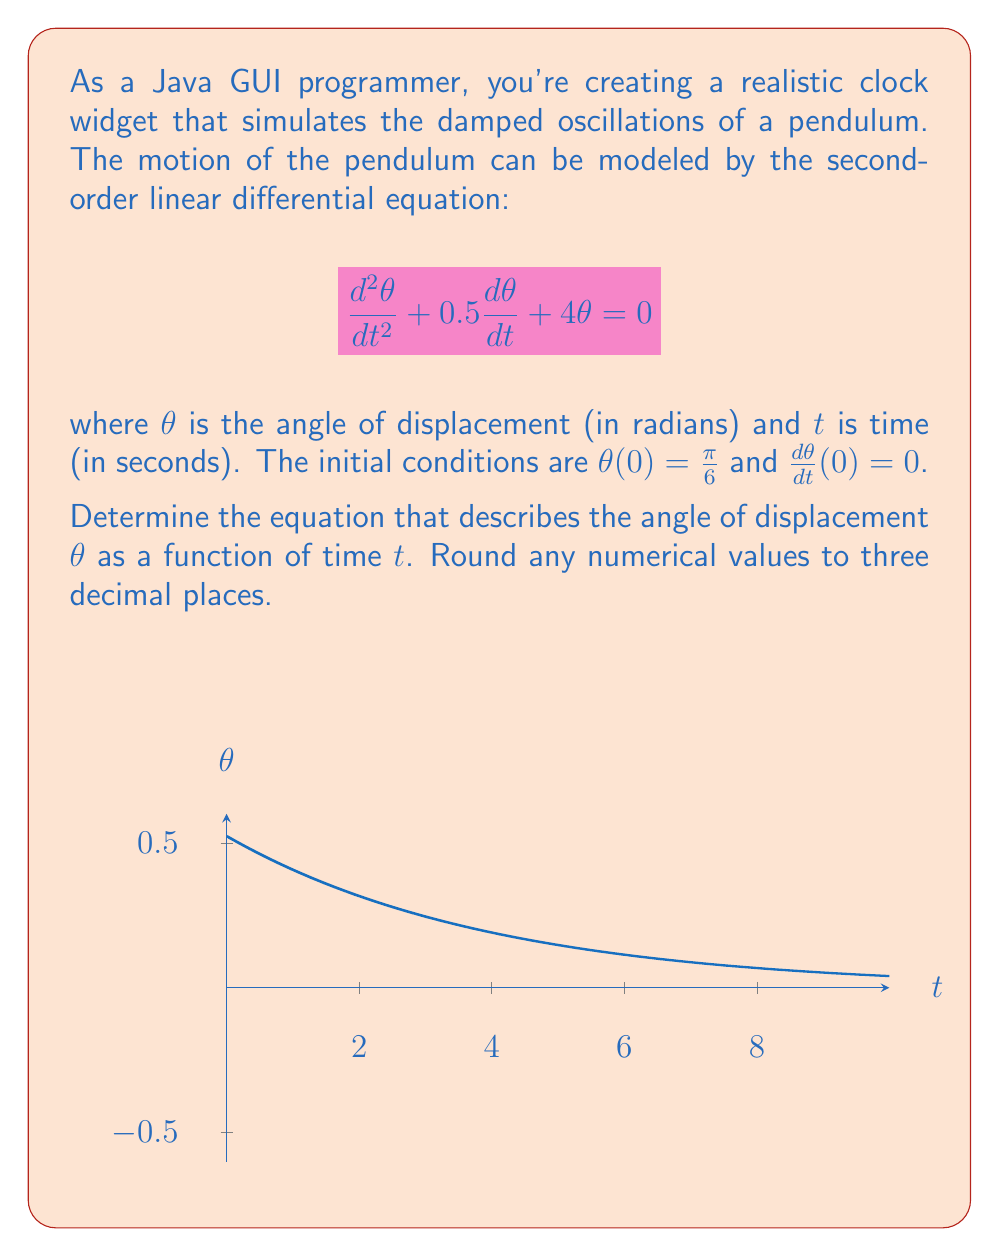Can you solve this math problem? Let's solve this step-by-step:

1) The general form of a second-order linear differential equation is:
   $$\frac{d^2\theta}{dt^2} + 2\zeta\omega_n\frac{d\theta}{dt} + \omega_n^2\theta = 0$$

2) Comparing our equation to this form, we can identify:
   $2\zeta\omega_n = 0.5$ and $\omega_n^2 = 4$

3) From $\omega_n^2 = 4$, we get $\omega_n = 2$

4) Substituting this back into $2\zeta\omega_n = 0.5$, we get:
   $2\zeta(2) = 0.5$
   $\zeta = 0.125$

5) Since $0 < \zeta < 1$, this is an underdamped system. The solution has the form:
   $$\theta(t) = Ae^{-\zeta\omega_n t}\cos(\omega_d t - \phi)$$

   where $\omega_d = \omega_n\sqrt{1-\zeta^2}$

6) Calculate $\omega_d$:
   $$\omega_d = 2\sqrt{1-0.125^2} = 1.984$$

7) The general solution is:
   $$\theta(t) = Ae^{-0.25t}\cos(1.984t - \phi)$$

8) Use the initial conditions to find $A$ and $\phi$:
   At $t=0$, $\theta(0) = \frac{\pi}{6} = 0.524$, so:
   $$0.524 = A\cos(\phi)$$

   The derivative of $\theta(t)$ is:
   $$\frac{d\theta}{dt} = -0.25Ae^{-0.25t}\cos(1.984t - \phi) - 1.984Ae^{-0.25t}\sin(1.984t - \phi)$$

   At $t=0$, $\frac{d\theta}{dt}(0) = 0$, so:
   $$0 = -0.25A\cos(\phi) - 1.984A\sin(\phi)$$

9) Solving these equations:
   $A = 0.524$ and $\phi = 0$

10) Therefore, the final solution is:
    $$\theta(t) = 0.524e^{-0.25t}\cos(1.984t)$$
Answer: $\theta(t) = 0.524e^{-0.25t}\cos(1.984t)$ 